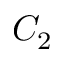<formula> <loc_0><loc_0><loc_500><loc_500>C _ { 2 }</formula> 